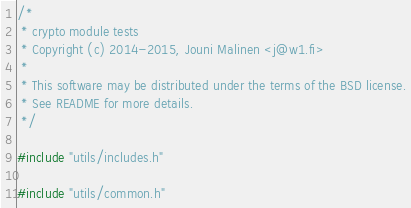<code> <loc_0><loc_0><loc_500><loc_500><_C_>/*
 * crypto module tests
 * Copyright (c) 2014-2015, Jouni Malinen <j@w1.fi>
 *
 * This software may be distributed under the terms of the BSD license.
 * See README for more details.
 */

#include "utils/includes.h"

#include "utils/common.h"</code> 